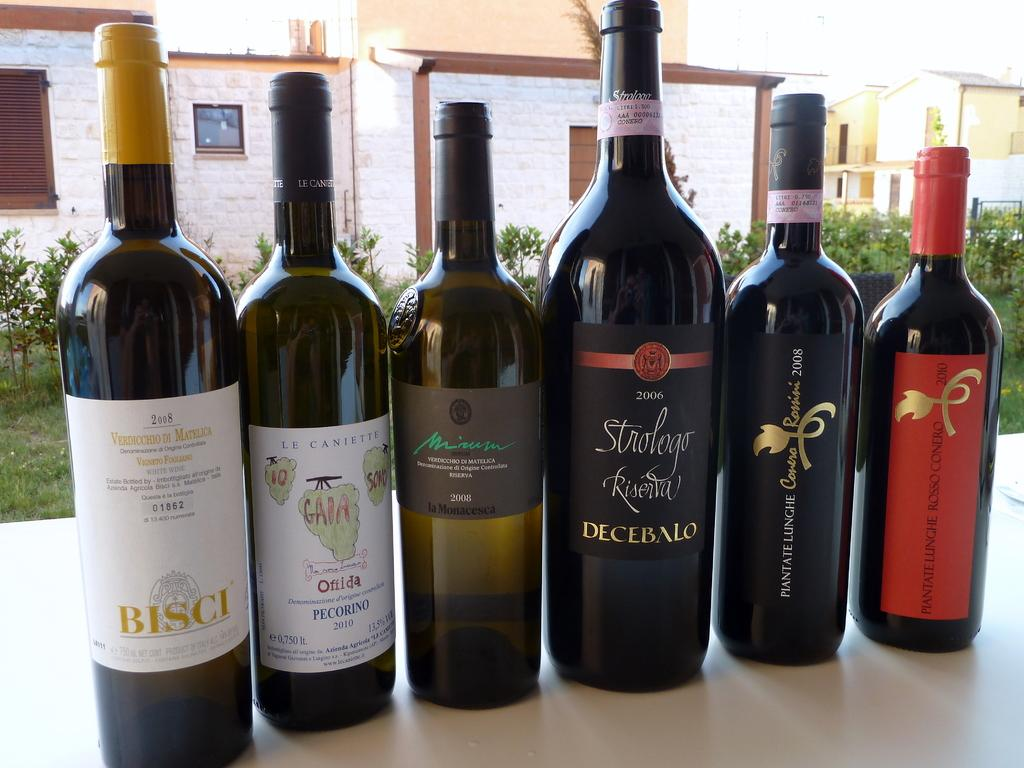Provide a one-sentence caption for the provided image. A bottle of 2008 Bisci wine is on the left of 5 other bottles from different companies. 